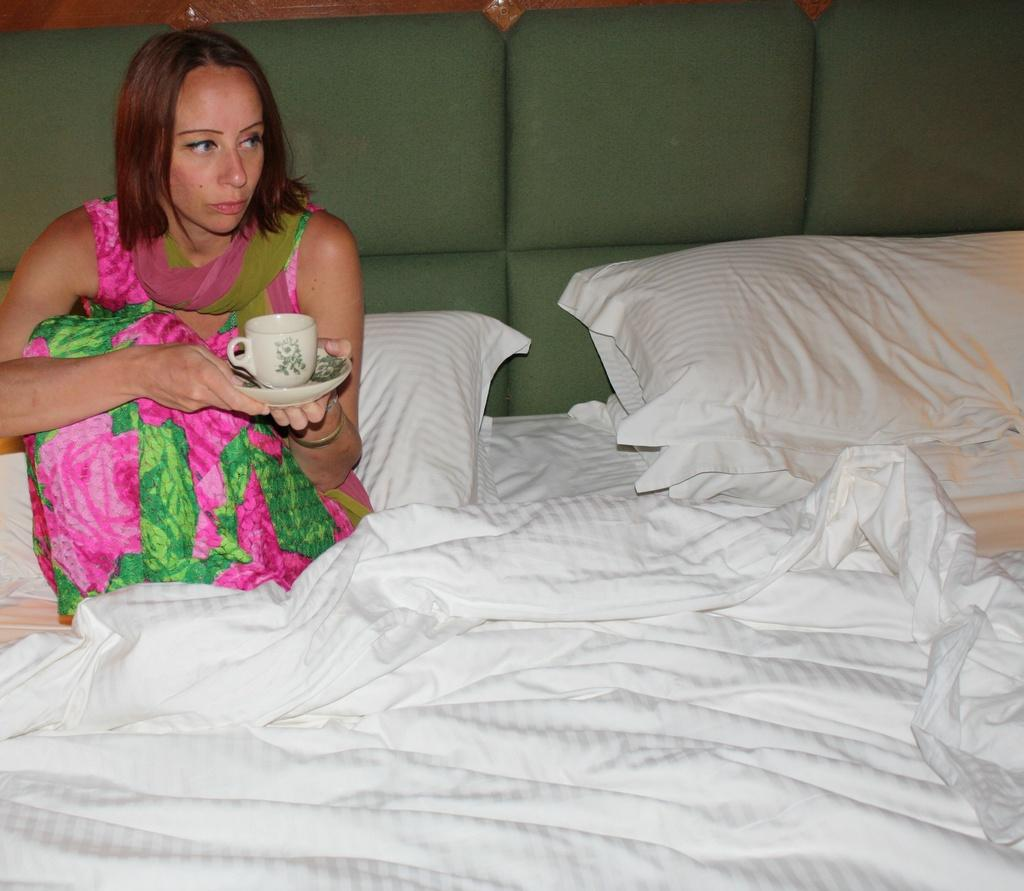Who is present in the image? There is a woman in the image. What is the woman doing in the image? The woman is sitting on a bed. What is the woman holding in the image? The woman is holding a tea cup. What other objects can be seen in the image? There is a pillow and a blanket in the image. What type of system is the woman using to crush the police in the image? There is no system, crushing, or police present in the image. 